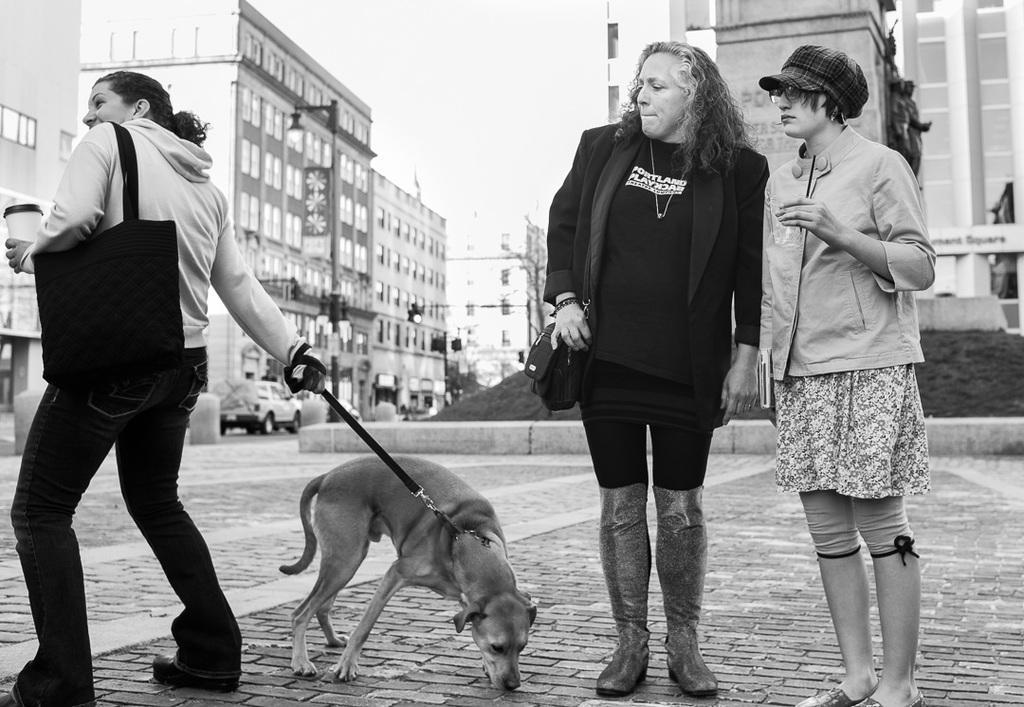Describe this image in one or two sentences. There are two woman standing on the right side of the image and there is a third woman holding a bag on her shoulder, holding a dog in her other hand. In the background there are some cars, buildings and sky here. 